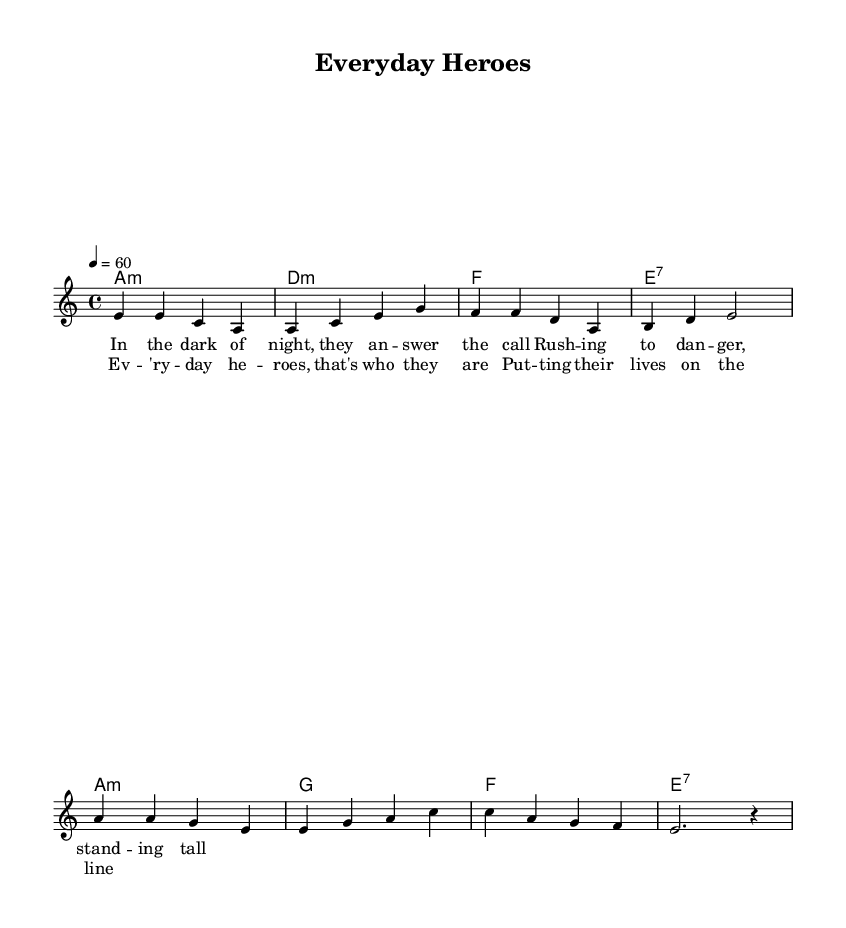What is the key signature of this music? The key signature is A minor, which has no sharps or flats.
Answer: A minor What is the time signature of the piece? The time signature is 4/4, which means there are four beats per measure.
Answer: 4/4 What is the tempo of the song? The tempo is set at 60 beats per minute, indicated by the marking “4 = 60.”
Answer: 60 How many measures are in the verse section? The verse section consists of four measures, as indicated by the notation layout corresponding to the melody.
Answer: 4 Which chord appears in the chorus? The chords in the chorus include A minor, G major, F major, and E7, as denoted in the chord section.
Answer: A minor, G major, F major, E7 What do the lyrics celebrate? The lyrics celebrate everyday heroes and first responders who rush to danger, reflecting a theme of courage and selflessness.
Answer: Everyday heroes How does the melody begin? The melody begins with two eighth notes followed by a half note: “e4 e” representing the first two notes in the verse.
Answer: e 